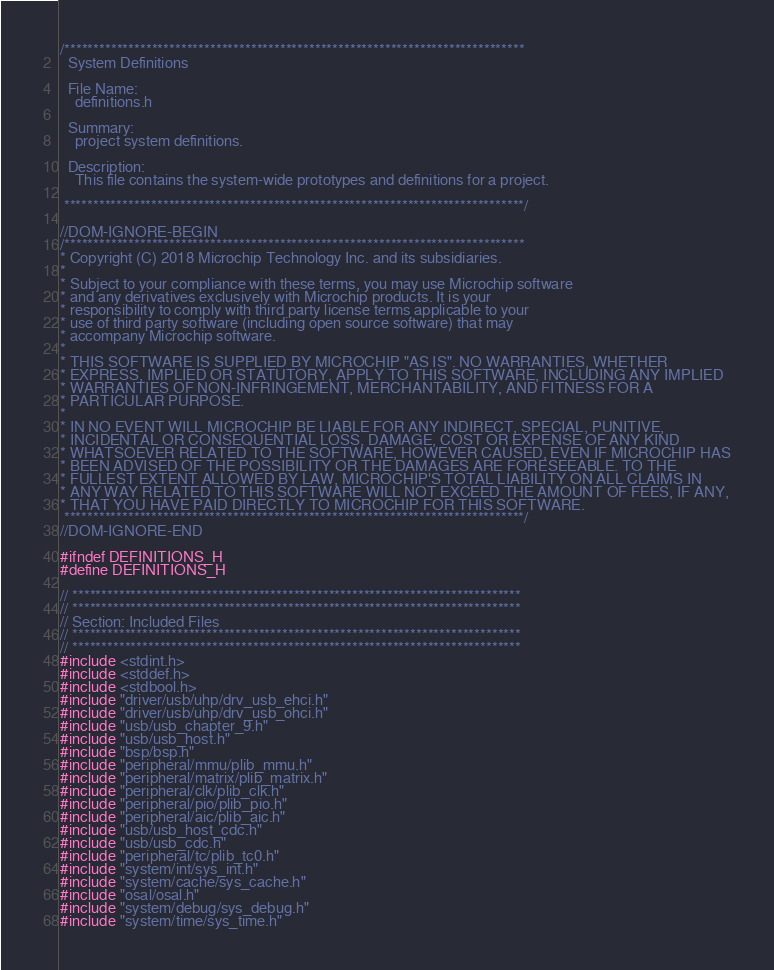Convert code to text. <code><loc_0><loc_0><loc_500><loc_500><_C_>/*******************************************************************************
  System Definitions

  File Name:
    definitions.h

  Summary:
    project system definitions.

  Description:
    This file contains the system-wide prototypes and definitions for a project.

 *******************************************************************************/

//DOM-IGNORE-BEGIN
/*******************************************************************************
* Copyright (C) 2018 Microchip Technology Inc. and its subsidiaries.
*
* Subject to your compliance with these terms, you may use Microchip software
* and any derivatives exclusively with Microchip products. It is your
* responsibility to comply with third party license terms applicable to your
* use of third party software (including open source software) that may
* accompany Microchip software.
*
* THIS SOFTWARE IS SUPPLIED BY MICROCHIP "AS IS". NO WARRANTIES, WHETHER
* EXPRESS, IMPLIED OR STATUTORY, APPLY TO THIS SOFTWARE, INCLUDING ANY IMPLIED
* WARRANTIES OF NON-INFRINGEMENT, MERCHANTABILITY, AND FITNESS FOR A
* PARTICULAR PURPOSE.
*
* IN NO EVENT WILL MICROCHIP BE LIABLE FOR ANY INDIRECT, SPECIAL, PUNITIVE,
* INCIDENTAL OR CONSEQUENTIAL LOSS, DAMAGE, COST OR EXPENSE OF ANY KIND
* WHATSOEVER RELATED TO THE SOFTWARE, HOWEVER CAUSED, EVEN IF MICROCHIP HAS
* BEEN ADVISED OF THE POSSIBILITY OR THE DAMAGES ARE FORESEEABLE. TO THE
* FULLEST EXTENT ALLOWED BY LAW, MICROCHIP'S TOTAL LIABILITY ON ALL CLAIMS IN
* ANY WAY RELATED TO THIS SOFTWARE WILL NOT EXCEED THE AMOUNT OF FEES, IF ANY,
* THAT YOU HAVE PAID DIRECTLY TO MICROCHIP FOR THIS SOFTWARE.
 *******************************************************************************/
//DOM-IGNORE-END

#ifndef DEFINITIONS_H
#define DEFINITIONS_H

// *****************************************************************************
// *****************************************************************************
// Section: Included Files
// *****************************************************************************
// *****************************************************************************
#include <stdint.h>
#include <stddef.h>
#include <stdbool.h>
#include "driver/usb/uhp/drv_usb_ehci.h"
#include "driver/usb/uhp/drv_usb_ohci.h"
#include "usb/usb_chapter_9.h"
#include "usb/usb_host.h"
#include "bsp/bsp.h"
#include "peripheral/mmu/plib_mmu.h"
#include "peripheral/matrix/plib_matrix.h"
#include "peripheral/clk/plib_clk.h"
#include "peripheral/pio/plib_pio.h"
#include "peripheral/aic/plib_aic.h"
#include "usb/usb_host_cdc.h"
#include "usb/usb_cdc.h"
#include "peripheral/tc/plib_tc0.h"
#include "system/int/sys_int.h"
#include "system/cache/sys_cache.h"
#include "osal/osal.h"
#include "system/debug/sys_debug.h"
#include "system/time/sys_time.h"</code> 